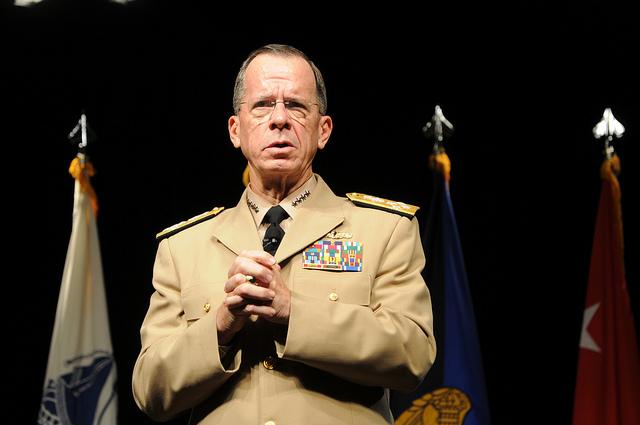Is this man in the military?
Quick response, please. Yes. Who is the man?
Be succinct. General. What color is the man's jacket?
Short answer required. Tan. 